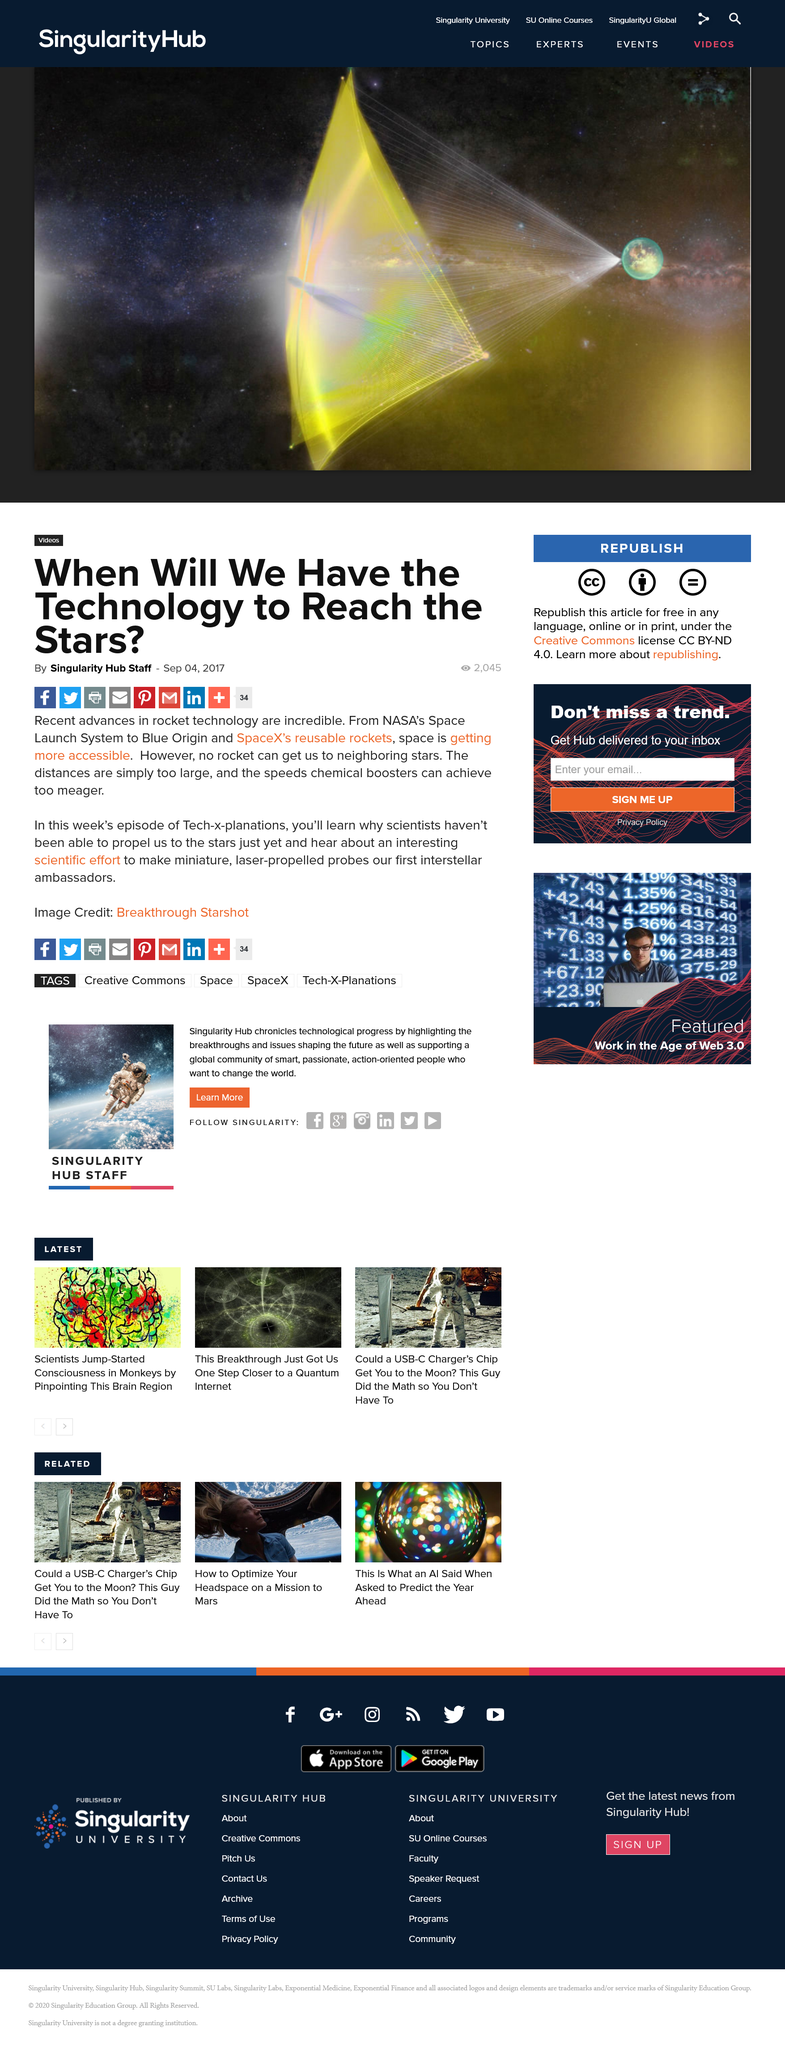Give some essential details in this illustration. The week's episode of Tech-x-planations will teach viewers about the scientific challenges preventing mankind from achieving interstellar travel. The reason we have not yet developed technology to travel to neighboring stars is due to the vast distances and limited speeds that current propulsion systems can achieve. It is definitively not possible for rockets to reach neighboring stars at this time. 